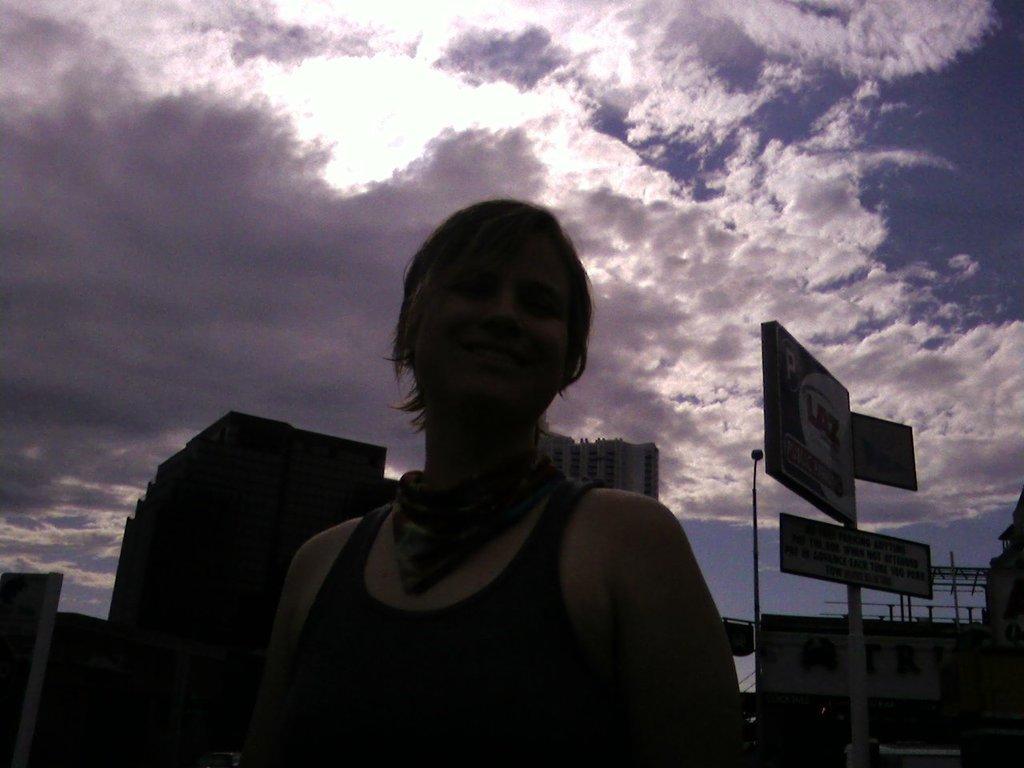Describe this image in one or two sentences. In this image we can see a woman is standing, and smiling, at the back there are buildings, there is hoarding, there is the pole, at above the sky is cloudy. 